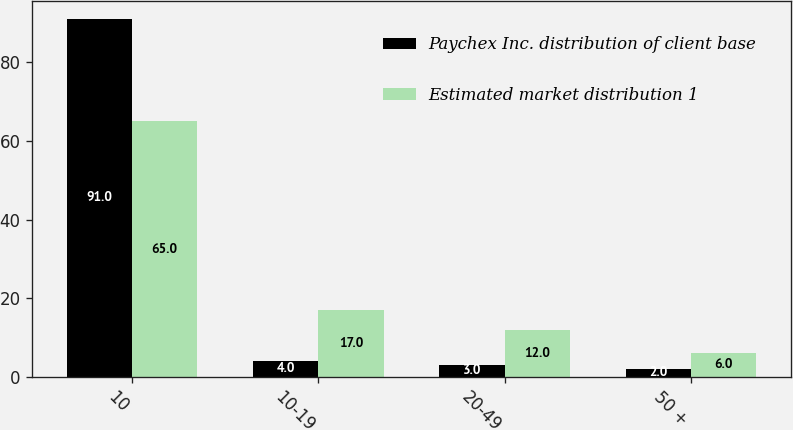<chart> <loc_0><loc_0><loc_500><loc_500><stacked_bar_chart><ecel><fcel>10<fcel>10-19<fcel>20-49<fcel>50 +<nl><fcel>Paychex Inc. distribution of client base<fcel>91<fcel>4<fcel>3<fcel>2<nl><fcel>Estimated market distribution 1<fcel>65<fcel>17<fcel>12<fcel>6<nl></chart> 